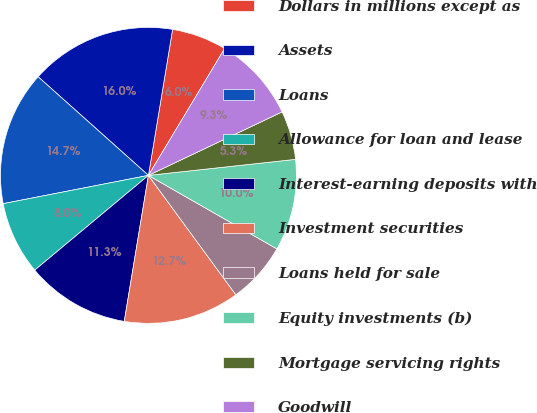Convert chart to OTSL. <chart><loc_0><loc_0><loc_500><loc_500><pie_chart><fcel>Dollars in millions except as<fcel>Assets<fcel>Loans<fcel>Allowance for loan and lease<fcel>Interest-earning deposits with<fcel>Investment securities<fcel>Loans held for sale<fcel>Equity investments (b)<fcel>Mortgage servicing rights<fcel>Goodwill<nl><fcel>6.0%<fcel>16.0%<fcel>14.67%<fcel>8.0%<fcel>11.33%<fcel>12.67%<fcel>6.67%<fcel>10.0%<fcel>5.33%<fcel>9.33%<nl></chart> 